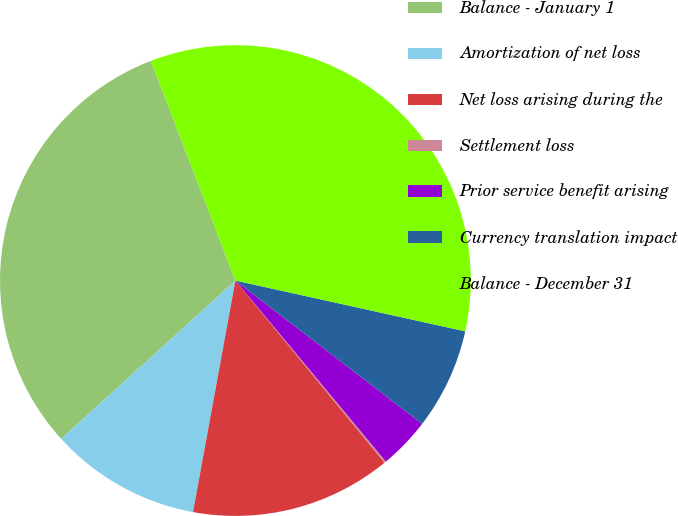Convert chart to OTSL. <chart><loc_0><loc_0><loc_500><loc_500><pie_chart><fcel>Balance - January 1<fcel>Amortization of net loss<fcel>Net loss arising during the<fcel>Settlement loss<fcel>Prior service benefit arising<fcel>Currency translation impact<fcel>Balance - December 31<nl><fcel>30.89%<fcel>10.38%<fcel>13.8%<fcel>0.12%<fcel>3.54%<fcel>6.96%<fcel>34.31%<nl></chart> 